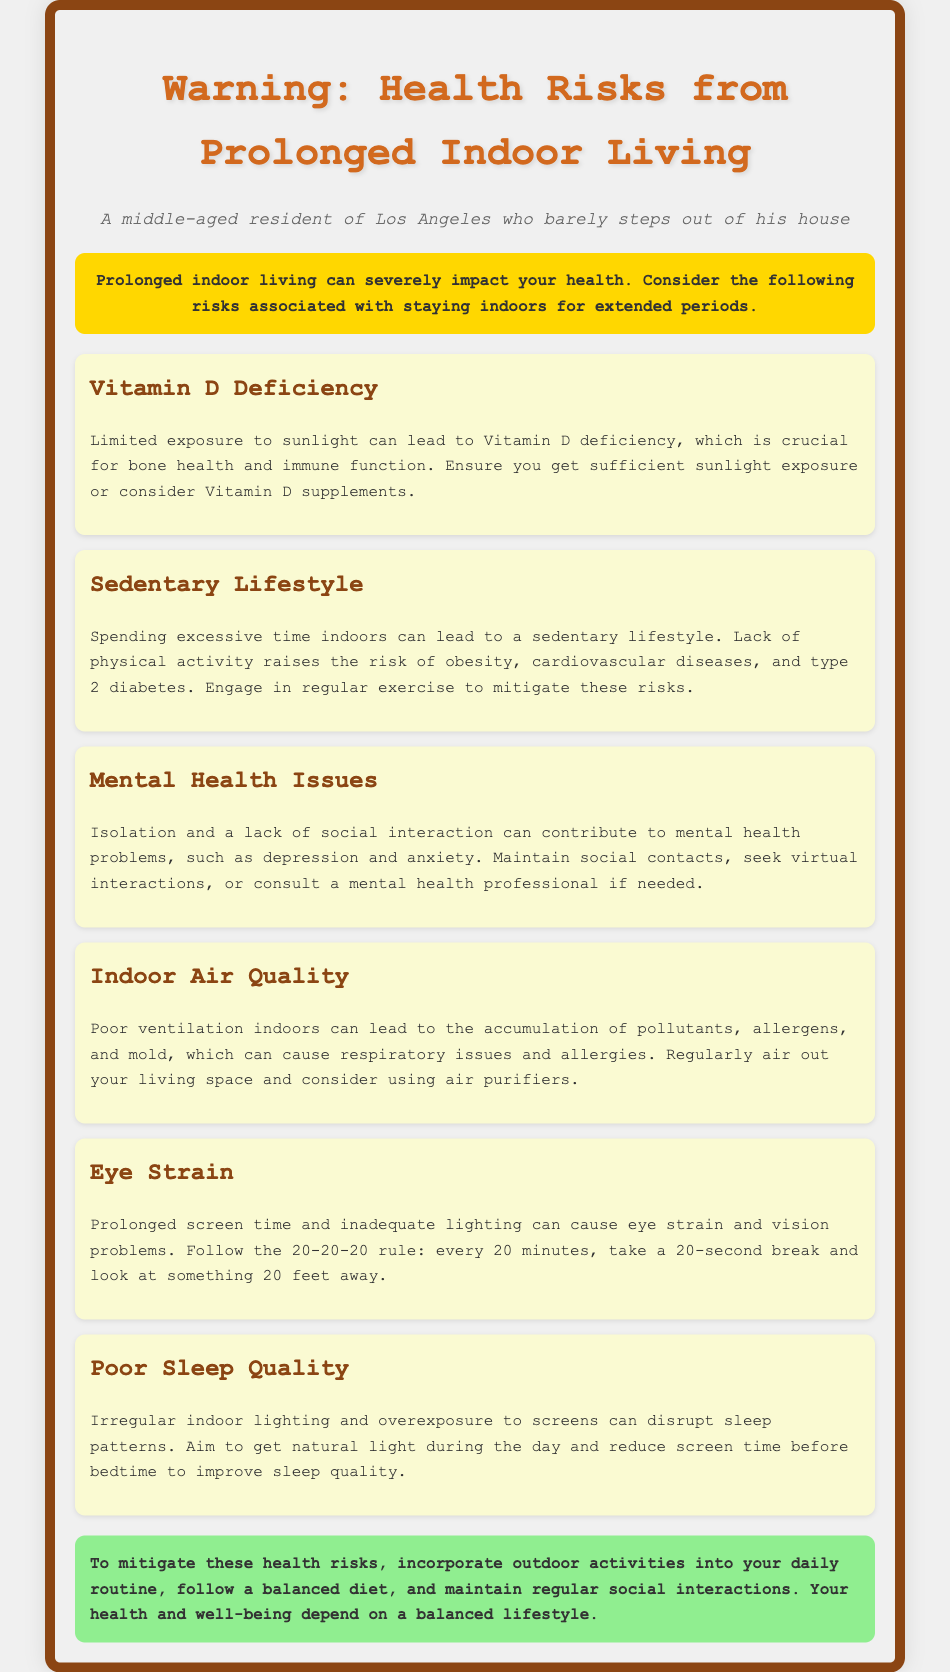What health risk is associated with limited sunlight exposure? The document mentions that limited exposure to sunlight can lead to Vitamin D deficiency, which is crucial for bone health and immune function.
Answer: Vitamin D deficiency What lifestyle issue is emphasized due to prolonged indoor living? The document highlights that spending excessive time indoors can lead to a sedentary lifestyle, increasing the risk of various diseases.
Answer: Sedentary lifestyle What is the 20-20-20 rule related to? The document describes the 20-20-20 rule as a method to reduce eye strain from prolonged screen time and inadequate lighting.
Answer: Eye strain What recommendation is given to improve sleep quality? The document suggests aiming to get natural light during the day and reducing screen time before bedtime to improve sleep quality.
Answer: Natural light and reduce screen time Which health issue may arise from poor indoor air quality? The document states that poor ventilation indoors can lead to respiratory issues and allergies due to accumulated pollutants and allergens.
Answer: Respiratory issues 